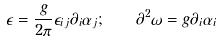<formula> <loc_0><loc_0><loc_500><loc_500>\epsilon = \frac { g } { 2 \pi } \epsilon _ { i j } \partial _ { i } \alpha _ { j } ; \quad \partial ^ { 2 } \omega = g \partial _ { i } \alpha _ { i }</formula> 